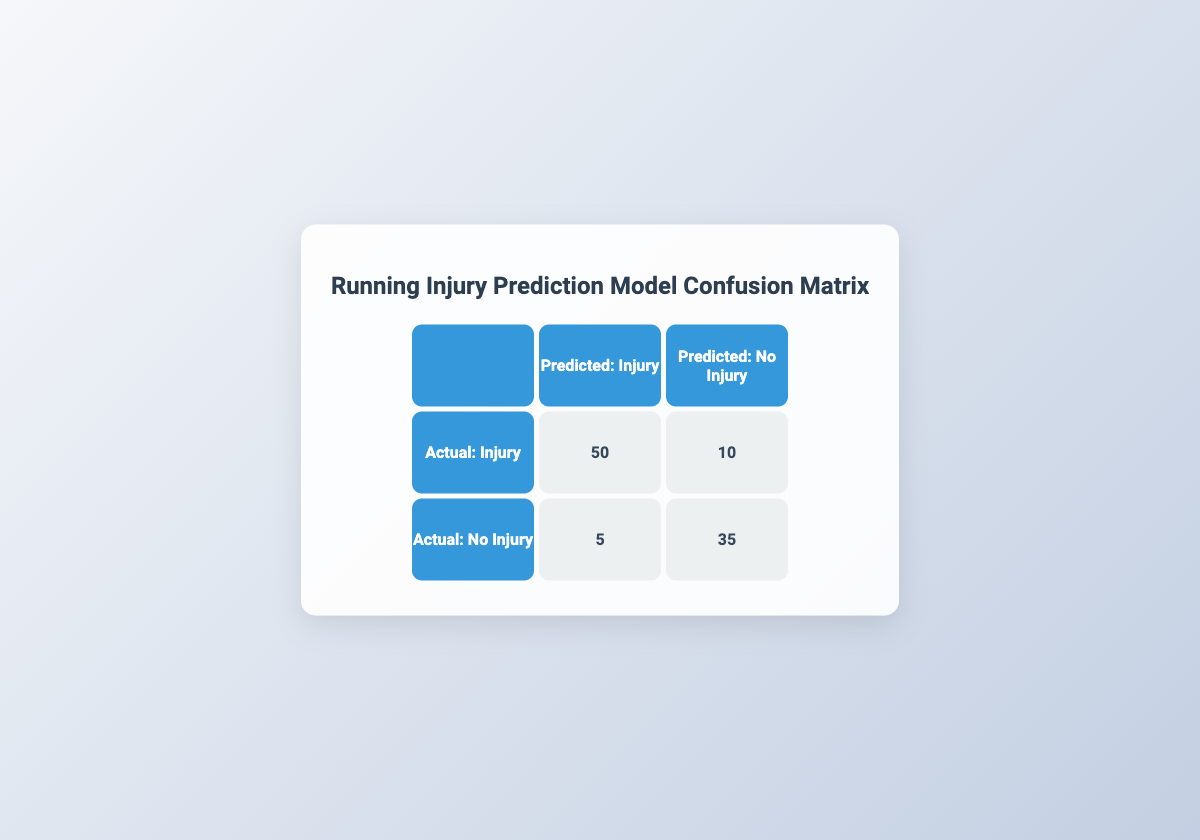What is the number of true positive predictions for injuries? The table shows that the count of true positive predictions for injuries, meaning cases where the model correctly predicted an injury, is 50.
Answer: 50 How many cases did the model incorrectly predict as injuries? The model incorrectly predicted 5 cases as injuries when the actual condition was no injury (false positives).
Answer: 5 What is the total number of actual injuries? To find the total actual injuries, add the true positives (50) and false negatives (10): 50 + 10 = 60.
Answer: 60 What fraction of the predictions were accurate overall? To find the overall accuracy, add the true positives (50) and true negatives (35), which gives 85 accurate predictions, and divide by the total number of cases (50 + 10 + 5 + 35 = 100). So, accuracy is 85/100 = 0.85 or 85%.
Answer: 85% Is it true that the model predicted more injuries than it actually detected? To determine this, we compare the total predicted injuries, which are true positives (50) plus false positives (5), totaling 55, against the actual injuries which are 60. The model predicted fewer injuries than were present (55 < 60).
Answer: No How many total cases were predicted as not an injury? The total cases predicted as not an injury include false negatives (10) and true negatives (35), thus 10 + 35 = 45.
Answer: 45 What is the ratio of true negatives to false positives? The true negatives are 35 and the false positives are 5. The ratio is calculated as 35:5, which simplifies to 7:1.
Answer: 7:1 What is the sum of true negatives and false negatives? The sum of true negatives (35) and false negatives (10) is calculated as 35 + 10 = 45.
Answer: 45 Are there more cases of true positive predictions than false negatives? The number of true positives is 50 and the number of false negatives is 10. Since 50 is greater than 10, the statement is true.
Answer: Yes 